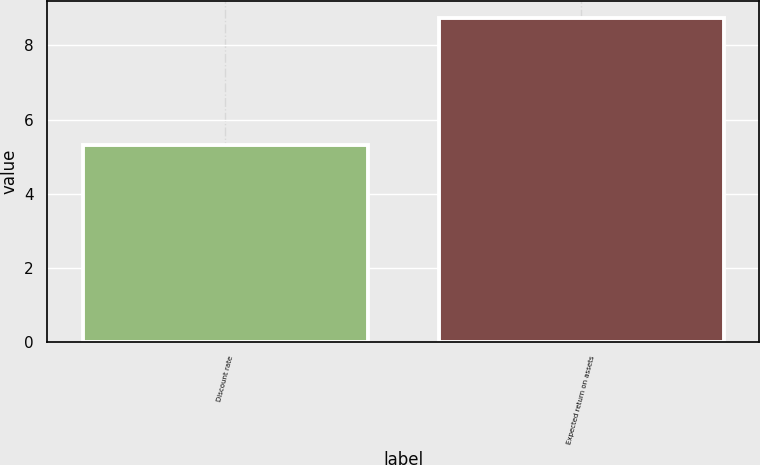Convert chart. <chart><loc_0><loc_0><loc_500><loc_500><bar_chart><fcel>Discount rate<fcel>Expected return on assets<nl><fcel>5.32<fcel>8.75<nl></chart> 